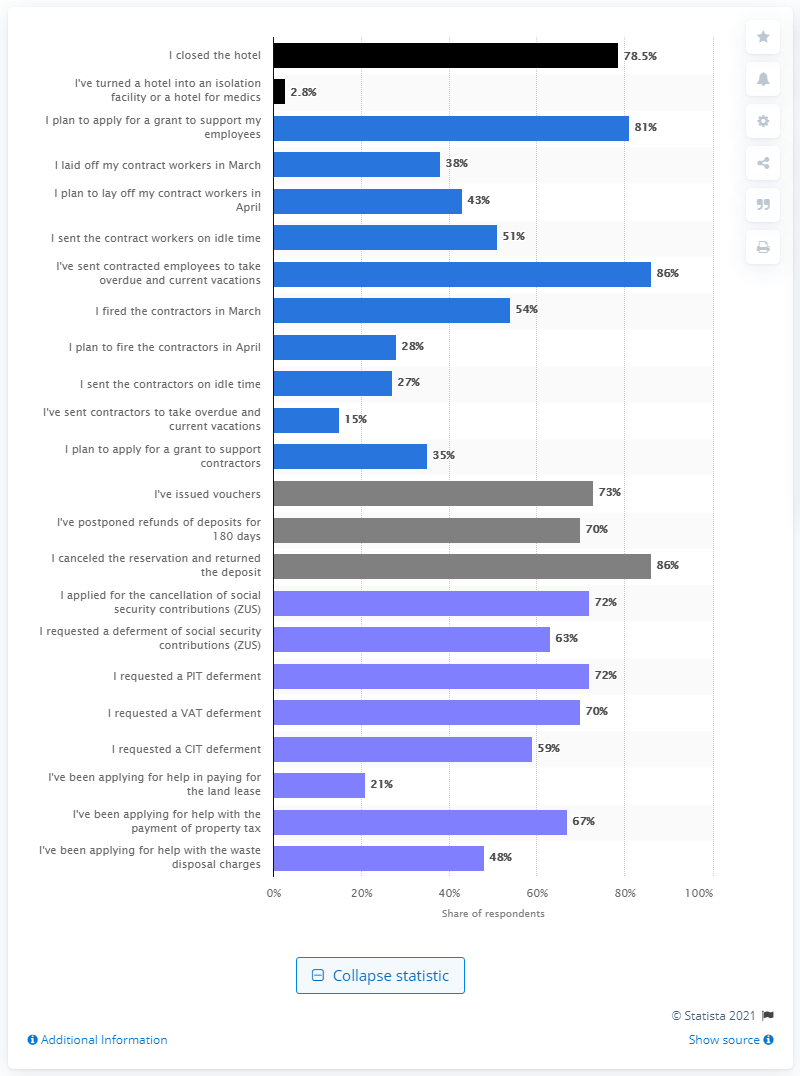Specify some key components in this picture. Seventy hotels issued vouchers in order to avoid being reimbursed for advance payments. 